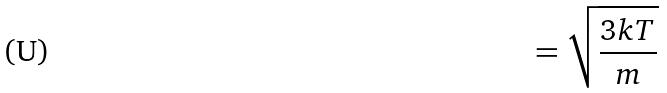<formula> <loc_0><loc_0><loc_500><loc_500>= \sqrt { \frac { 3 k T } { m } }</formula> 